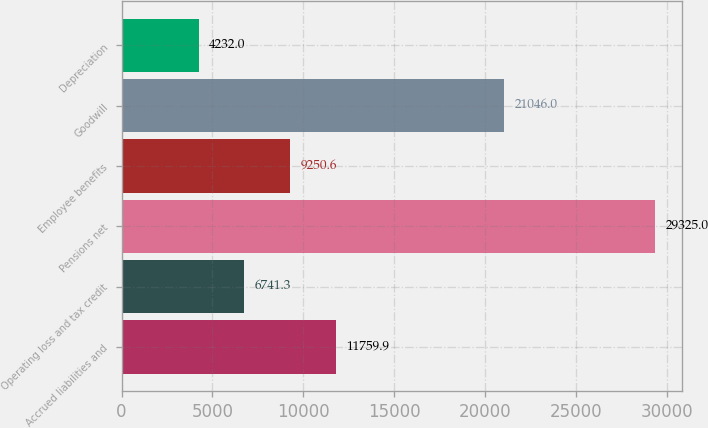<chart> <loc_0><loc_0><loc_500><loc_500><bar_chart><fcel>Accrued liabilities and<fcel>Operating loss and tax credit<fcel>Pensions net<fcel>Employee benefits<fcel>Goodwill<fcel>Depreciation<nl><fcel>11759.9<fcel>6741.3<fcel>29325<fcel>9250.6<fcel>21046<fcel>4232<nl></chart> 